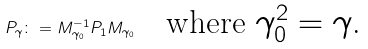<formula> <loc_0><loc_0><loc_500><loc_500>P _ { \gamma } \colon = M _ { \gamma _ { 0 } } ^ { - 1 } P _ { 1 } M _ { \gamma _ { 0 } } \quad \text {where $\gamma_{0}^{2}=\gamma$.}</formula> 